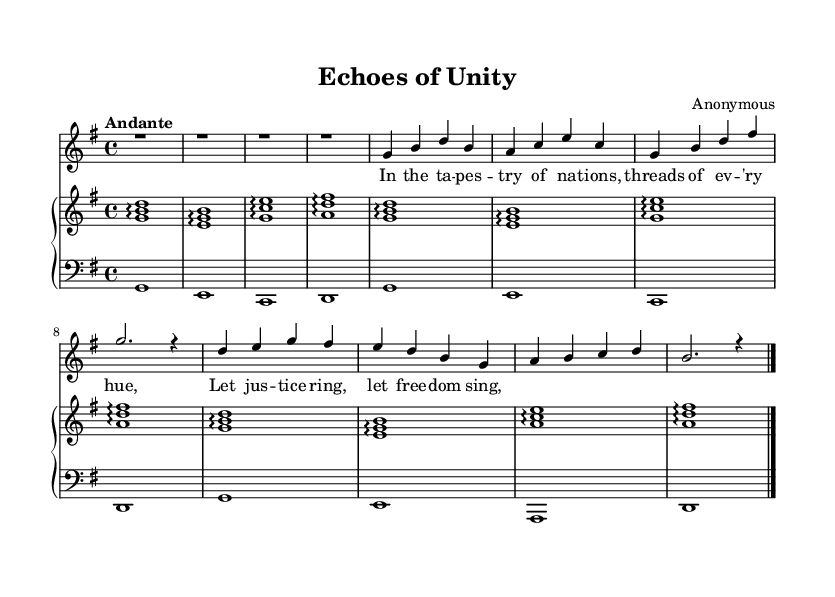What is the key signature of this music? The key signature has one sharp, indicating it is in G major.
Answer: G major What is the time signature of this music? The time signature is 4/4, which means there are four beats in each measure.
Answer: 4/4 What is the tempo marking of this music? The tempo marking indicates a speed of Andante, which is a moderate pace.
Answer: Andante How many measures are in the piece? The piece consists of 8 measures, counting each group of bars separated by the vertical lines.
Answer: 8 What type of song is this? This song is categorized as a Romantic art song, which typically addresses themes of emotion and social issues.
Answer: Romantic art song What is the emotional theme addressed in the lyrics? The lyrics convey a theme of justice and freedom, expressed through the metaphor of threads from nations.
Answer: Justice and freedom Which dynamic markings are present in the voice part? The voice part features a dynamic marking of "dynamicUp," indicating the singer should project their voice upwards in dynamics.
Answer: dynamicUp 